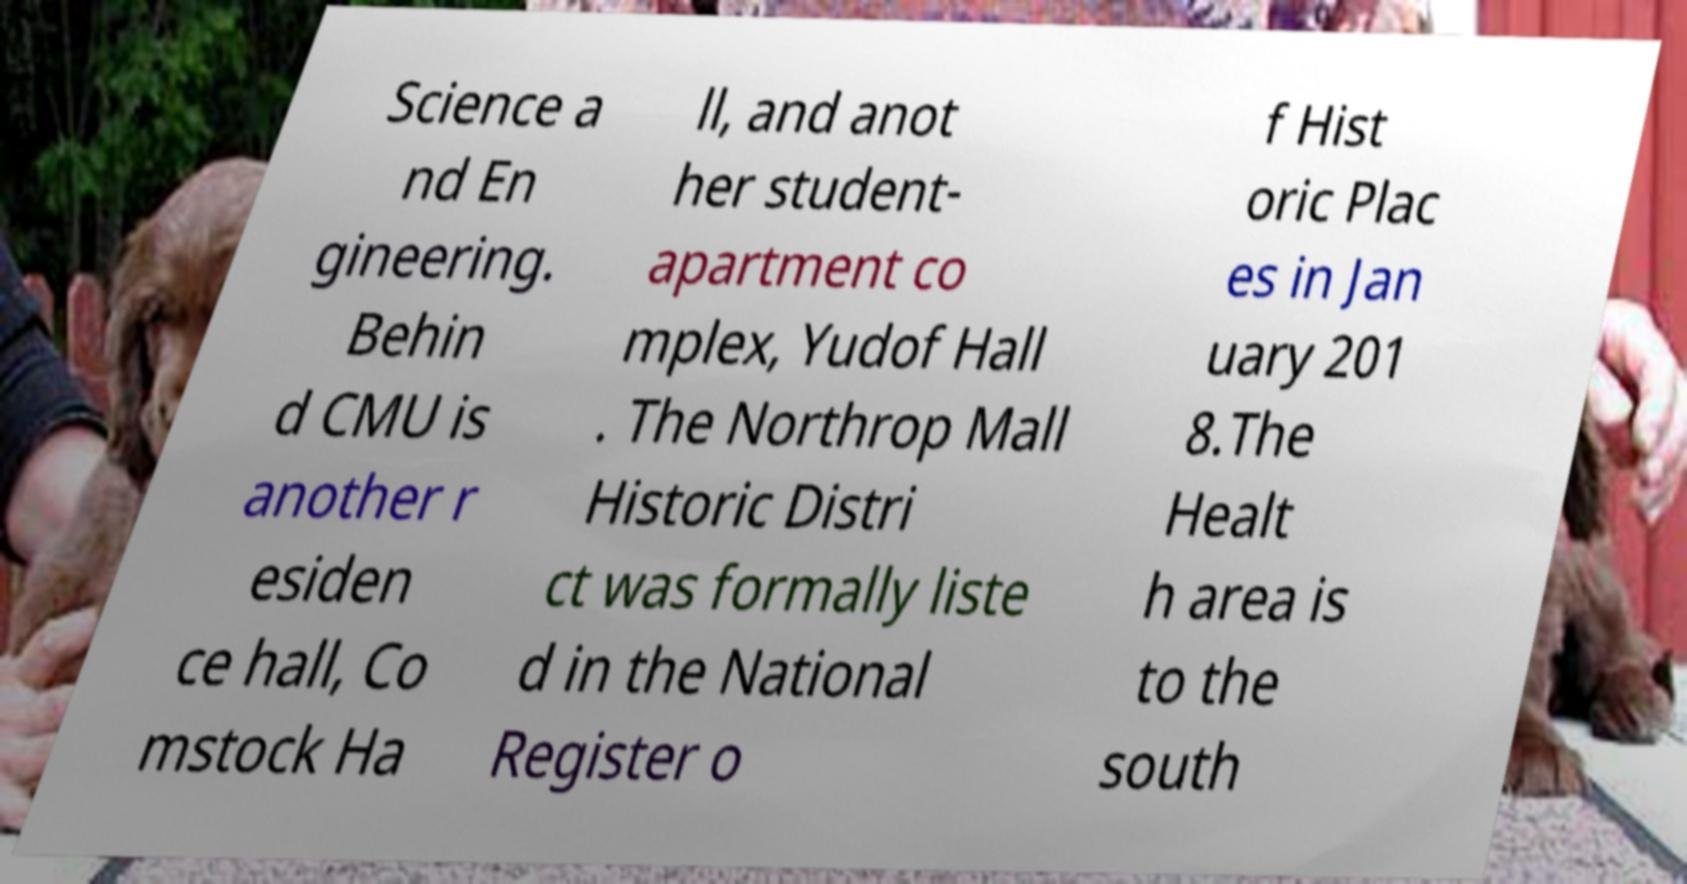Please read and relay the text visible in this image. What does it say? Science a nd En gineering. Behin d CMU is another r esiden ce hall, Co mstock Ha ll, and anot her student- apartment co mplex, Yudof Hall . The Northrop Mall Historic Distri ct was formally liste d in the National Register o f Hist oric Plac es in Jan uary 201 8.The Healt h area is to the south 